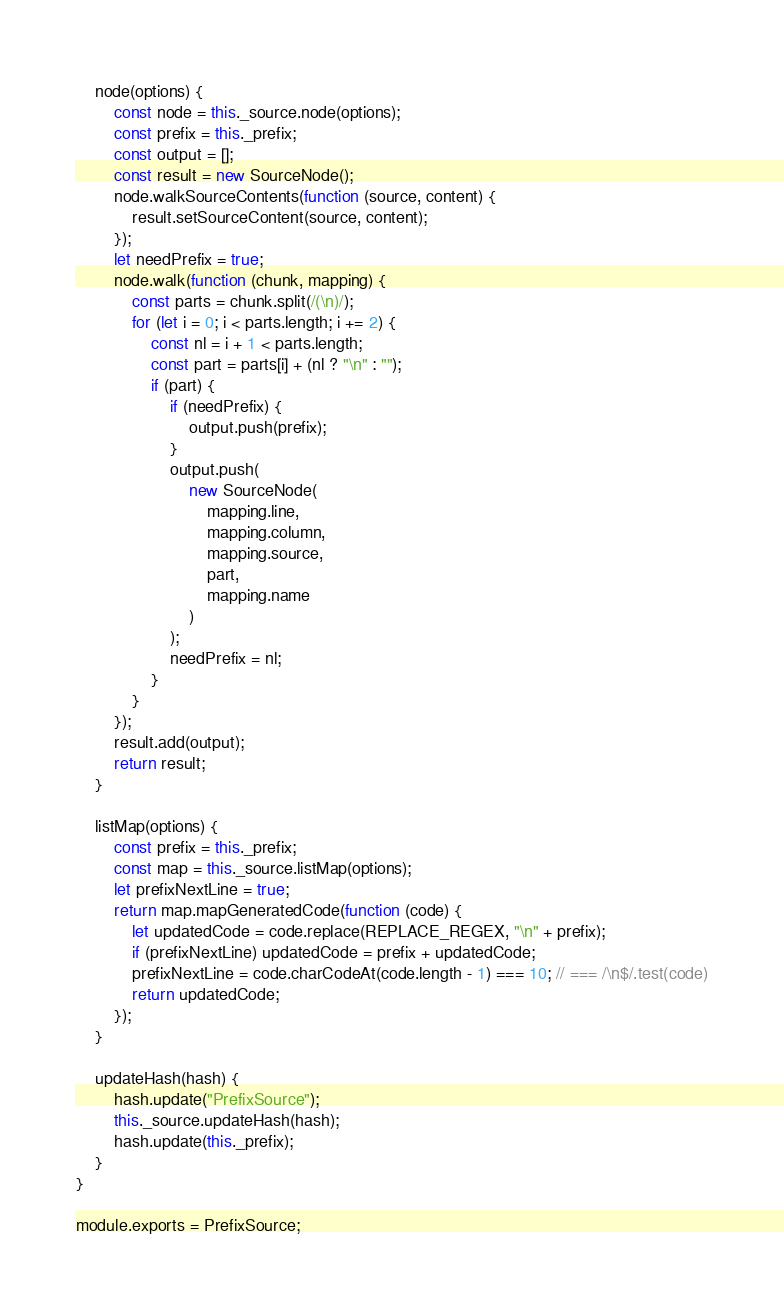Convert code to text. <code><loc_0><loc_0><loc_500><loc_500><_JavaScript_>	node(options) {
		const node = this._source.node(options);
		const prefix = this._prefix;
		const output = [];
		const result = new SourceNode();
		node.walkSourceContents(function (source, content) {
			result.setSourceContent(source, content);
		});
		let needPrefix = true;
		node.walk(function (chunk, mapping) {
			const parts = chunk.split(/(\n)/);
			for (let i = 0; i < parts.length; i += 2) {
				const nl = i + 1 < parts.length;
				const part = parts[i] + (nl ? "\n" : "");
				if (part) {
					if (needPrefix) {
						output.push(prefix);
					}
					output.push(
						new SourceNode(
							mapping.line,
							mapping.column,
							mapping.source,
							part,
							mapping.name
						)
					);
					needPrefix = nl;
				}
			}
		});
		result.add(output);
		return result;
	}

	listMap(options) {
		const prefix = this._prefix;
		const map = this._source.listMap(options);
		let prefixNextLine = true;
		return map.mapGeneratedCode(function (code) {
			let updatedCode = code.replace(REPLACE_REGEX, "\n" + prefix);
			if (prefixNextLine) updatedCode = prefix + updatedCode;
			prefixNextLine = code.charCodeAt(code.length - 1) === 10; // === /\n$/.test(code)
			return updatedCode;
		});
	}

	updateHash(hash) {
		hash.update("PrefixSource");
		this._source.updateHash(hash);
		hash.update(this._prefix);
	}
}

module.exports = PrefixSource;
</code> 